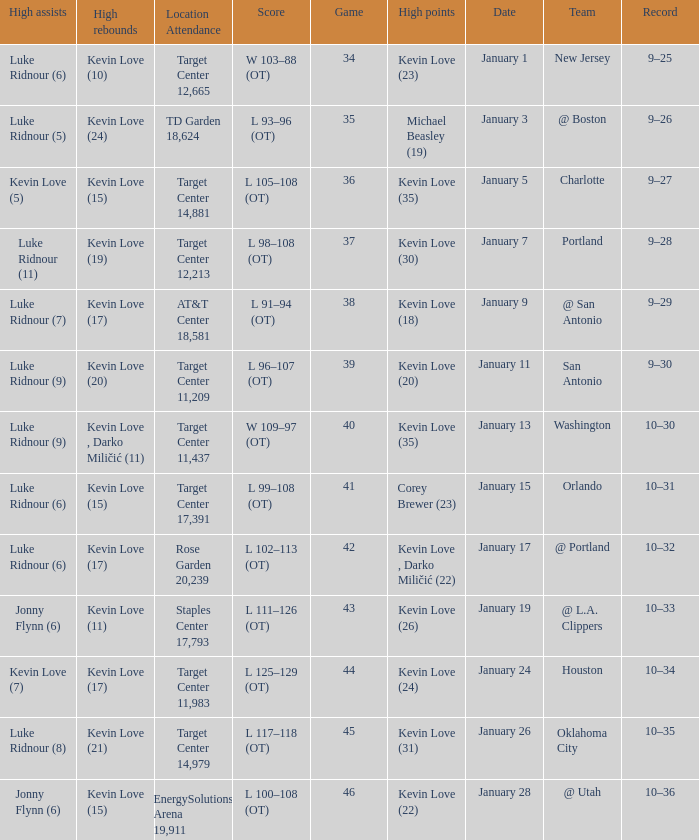What is the highest game with team @ l.a. clippers? 43.0. 